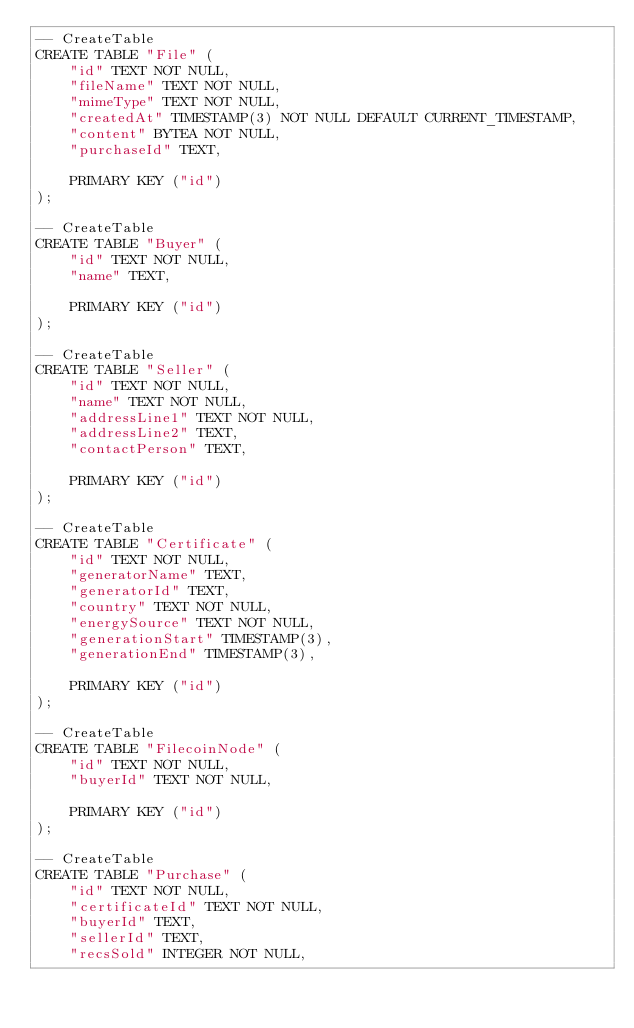Convert code to text. <code><loc_0><loc_0><loc_500><loc_500><_SQL_>-- CreateTable
CREATE TABLE "File" (
    "id" TEXT NOT NULL,
    "fileName" TEXT NOT NULL,
    "mimeType" TEXT NOT NULL,
    "createdAt" TIMESTAMP(3) NOT NULL DEFAULT CURRENT_TIMESTAMP,
    "content" BYTEA NOT NULL,
    "purchaseId" TEXT,

    PRIMARY KEY ("id")
);

-- CreateTable
CREATE TABLE "Buyer" (
    "id" TEXT NOT NULL,
    "name" TEXT,

    PRIMARY KEY ("id")
);

-- CreateTable
CREATE TABLE "Seller" (
    "id" TEXT NOT NULL,
    "name" TEXT NOT NULL,
    "addressLine1" TEXT NOT NULL,
    "addressLine2" TEXT,
    "contactPerson" TEXT,

    PRIMARY KEY ("id")
);

-- CreateTable
CREATE TABLE "Certificate" (
    "id" TEXT NOT NULL,
    "generatorName" TEXT,
    "generatorId" TEXT,
    "country" TEXT NOT NULL,
    "energySource" TEXT NOT NULL,
    "generationStart" TIMESTAMP(3),
    "generationEnd" TIMESTAMP(3),

    PRIMARY KEY ("id")
);

-- CreateTable
CREATE TABLE "FilecoinNode" (
    "id" TEXT NOT NULL,
    "buyerId" TEXT NOT NULL,

    PRIMARY KEY ("id")
);

-- CreateTable
CREATE TABLE "Purchase" (
    "id" TEXT NOT NULL,
    "certificateId" TEXT NOT NULL,
    "buyerId" TEXT,
    "sellerId" TEXT,
    "recsSold" INTEGER NOT NULL,</code> 